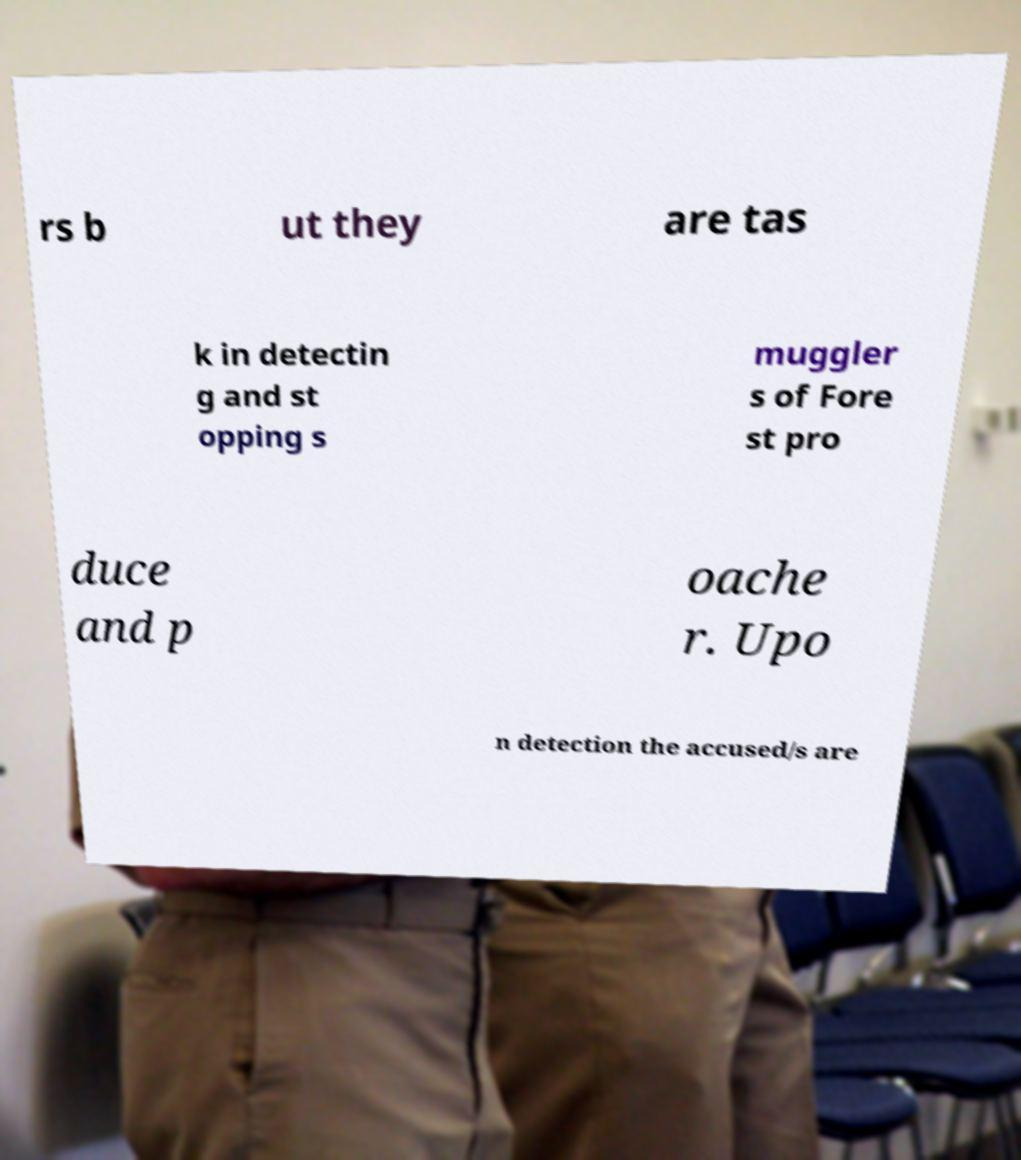What messages or text are displayed in this image? I need them in a readable, typed format. rs b ut they are tas k in detectin g and st opping s muggler s of Fore st pro duce and p oache r. Upo n detection the accused/s are 